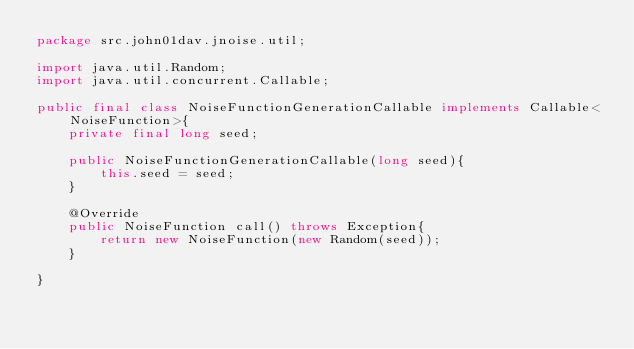<code> <loc_0><loc_0><loc_500><loc_500><_Java_>package src.john01dav.jnoise.util;

import java.util.Random;
import java.util.concurrent.Callable;

public final class NoiseFunctionGenerationCallable implements Callable<NoiseFunction>{
    private final long seed;

    public NoiseFunctionGenerationCallable(long seed){
        this.seed = seed;
    }

    @Override
    public NoiseFunction call() throws Exception{
        return new NoiseFunction(new Random(seed));
    }

}
</code> 